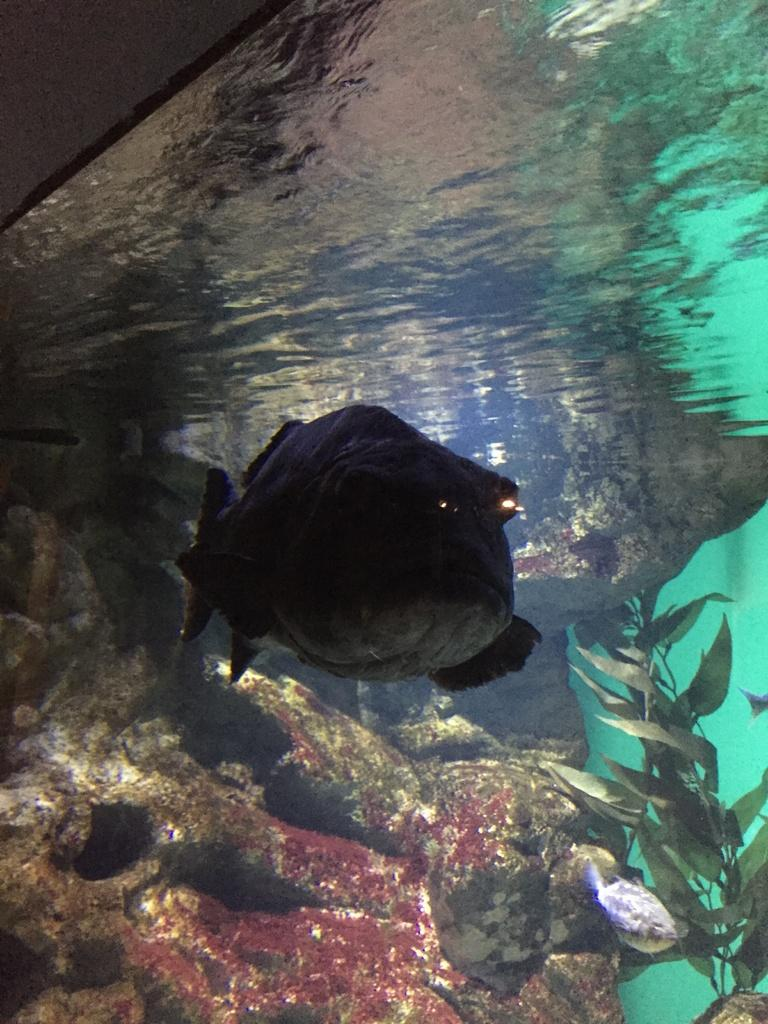What type of animals can be seen in the image? There are fishes in the image. Where are the fishes located? The fishes are swimming inside an aquarium. How many oranges are being supported by the dogs in the image? There are no oranges or dogs present in the image. 